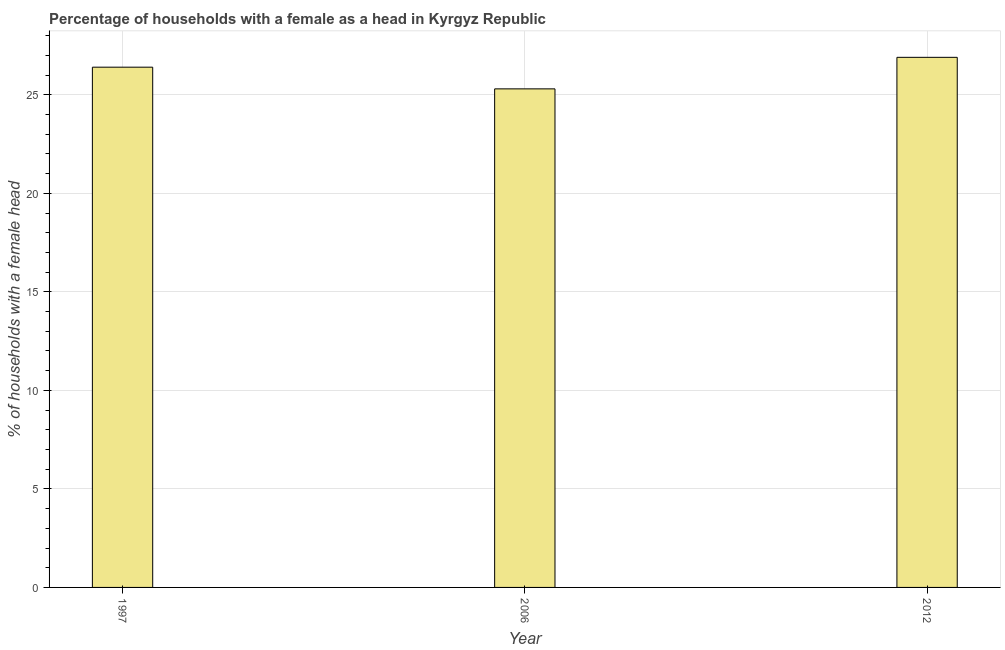Does the graph contain any zero values?
Offer a terse response. No. What is the title of the graph?
Make the answer very short. Percentage of households with a female as a head in Kyrgyz Republic. What is the label or title of the X-axis?
Offer a very short reply. Year. What is the label or title of the Y-axis?
Your answer should be very brief. % of households with a female head. What is the number of female supervised households in 1997?
Provide a succinct answer. 26.4. Across all years, what is the maximum number of female supervised households?
Offer a terse response. 26.9. Across all years, what is the minimum number of female supervised households?
Make the answer very short. 25.3. In which year was the number of female supervised households minimum?
Provide a succinct answer. 2006. What is the sum of the number of female supervised households?
Offer a very short reply. 78.6. What is the difference between the number of female supervised households in 2006 and 2012?
Make the answer very short. -1.6. What is the average number of female supervised households per year?
Your answer should be compact. 26.2. What is the median number of female supervised households?
Your answer should be compact. 26.4. Do a majority of the years between 1997 and 2012 (inclusive) have number of female supervised households greater than 3 %?
Keep it short and to the point. Yes. What is the ratio of the number of female supervised households in 2006 to that in 2012?
Offer a very short reply. 0.94. Is the number of female supervised households in 2006 less than that in 2012?
Give a very brief answer. Yes. Is the difference between the number of female supervised households in 1997 and 2012 greater than the difference between any two years?
Offer a terse response. No. What is the difference between the highest and the second highest number of female supervised households?
Provide a succinct answer. 0.5. Is the sum of the number of female supervised households in 1997 and 2006 greater than the maximum number of female supervised households across all years?
Give a very brief answer. Yes. What is the difference between the highest and the lowest number of female supervised households?
Provide a succinct answer. 1.6. How many bars are there?
Your response must be concise. 3. Are all the bars in the graph horizontal?
Offer a terse response. No. How many years are there in the graph?
Offer a very short reply. 3. What is the % of households with a female head in 1997?
Ensure brevity in your answer.  26.4. What is the % of households with a female head of 2006?
Offer a very short reply. 25.3. What is the % of households with a female head in 2012?
Provide a short and direct response. 26.9. What is the difference between the % of households with a female head in 1997 and 2006?
Offer a terse response. 1.1. What is the ratio of the % of households with a female head in 1997 to that in 2006?
Your answer should be very brief. 1.04. What is the ratio of the % of households with a female head in 2006 to that in 2012?
Offer a very short reply. 0.94. 